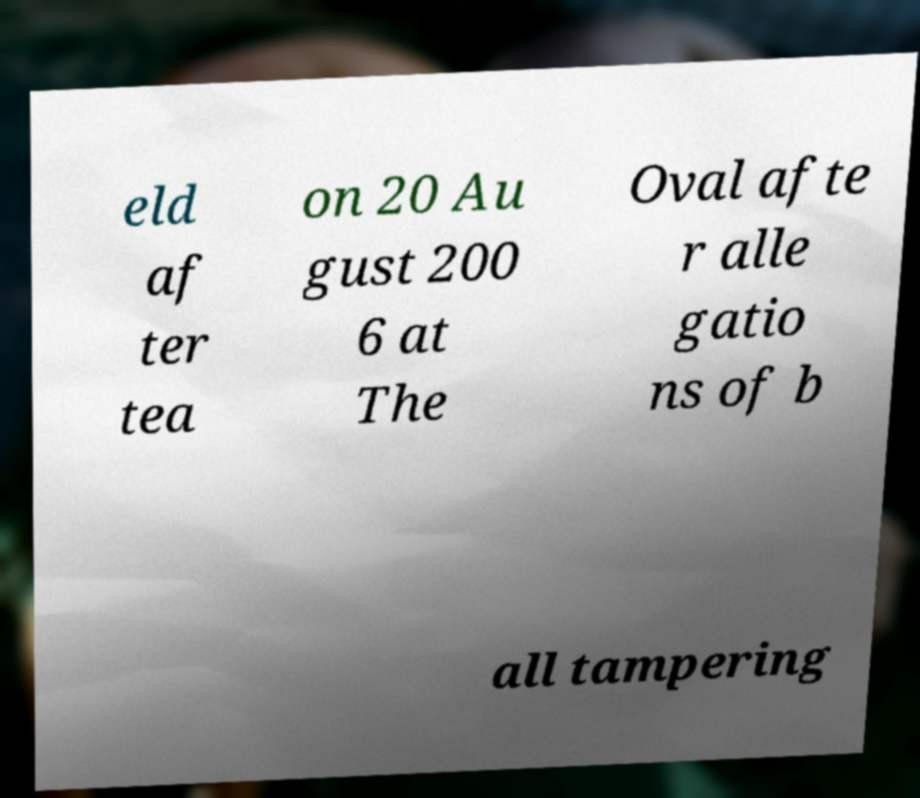What messages or text are displayed in this image? I need them in a readable, typed format. eld af ter tea on 20 Au gust 200 6 at The Oval afte r alle gatio ns of b all tampering 